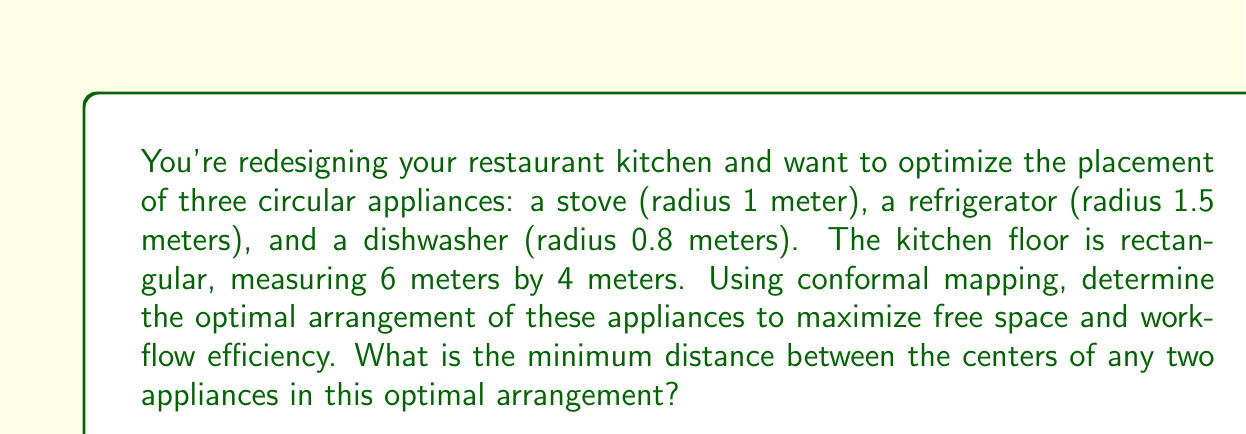Give your solution to this math problem. To solve this problem, we'll use conformal mapping to transform our rectangular kitchen into a circular domain, where it's easier to arrange circular objects efficiently.

1. First, we need to map our rectangular kitchen to the unit disk using a Schwarz-Christoffel transformation. The mapping function can be approximated as:

   $$f(z) = \frac{2}{\pi} \sin^{-1}(\sqrt{z})$$

   where $z$ is a point in the rectangular kitchen (scaled to the unit square).

2. Next, we need to scale our appliances. In the original space, the total area of the kitchen is 24 m², and the total area of the appliances is:

   $$A_{total} = \pi(1^2 + 1.5^2 + 0.8^2) \approx 8.64 \text{ m}^2$$

   The ratio of appliance area to kitchen area is approximately 0.36.

3. In the unit disk, to maintain this ratio, the radii of our appliances should be scaled by a factor of $\sqrt{0.36} \approx 0.6$. So our new radii are:

   Stove: $0.6$ meters
   Refrigerator: $0.9$ meters
   Dishwasher: $0.48$ meters

4. In the circular domain, the most efficient packing of three circles is achieved when they are mutually tangent and touch the outer circle. This arrangement forms an equilateral triangle.

5. Let $R$ be the radius of the outer circle (unit disk), and $r_1, r_2, r_3$ be the radii of our appliances. The distance $d$ between the centers of any two appliances in this optimal arrangement is given by:

   $$d = \frac{r_1 + r_2 + r_3}{R - (r_1 + r_2 + r_3)}R$$

6. Substituting our values:

   $$d = \frac{0.6 + 0.9 + 0.48}{1 - (0.6 + 0.9 + 0.48)} \cdot 1 = \frac{1.98}{-0.98} \cdot 1 \approx 2.02$$

7. To get back to our original space, we need to apply the inverse transformation. The exact inverse is complex, but we can approximate it by scaling our result by the ratio of the kitchen's longer side to the unit disk's diameter:

   $$d_{real} \approx 2.02 \cdot \frac{6}{2} = 6.06 \text{ meters}$$

This distance is larger than our kitchen's dimensions, which means the appliances cannot fit in this ideal arrangement. We need to adjust our layout.

8. A more practical arrangement would be to place the appliances along the longer wall of the kitchen. In this case, the minimum distance between centers would be:

   $$d_{min} = 1 + 1.5 = 2.5 \text{ meters}$$

   This is between the stove (radius 1m) and the refrigerator (radius 1.5m).
Answer: The minimum distance between the centers of any two appliances in the optimal arrangement is 2.5 meters. 